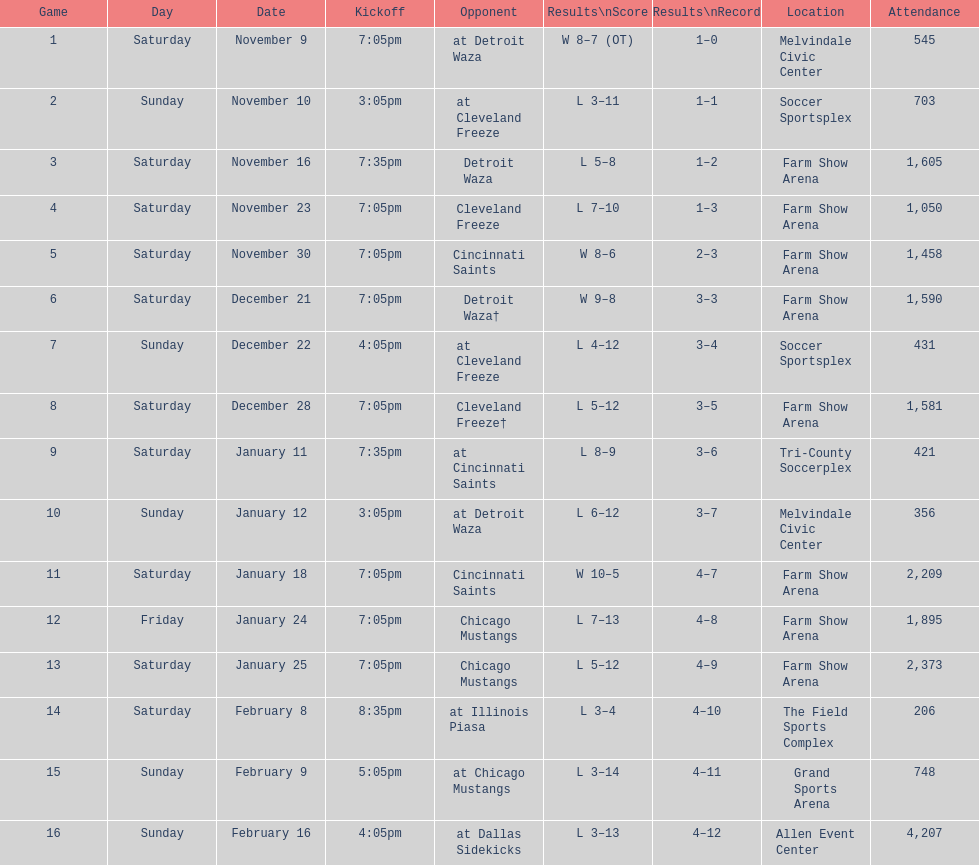Which opponent is listed first in the table? Detroit Waza. 